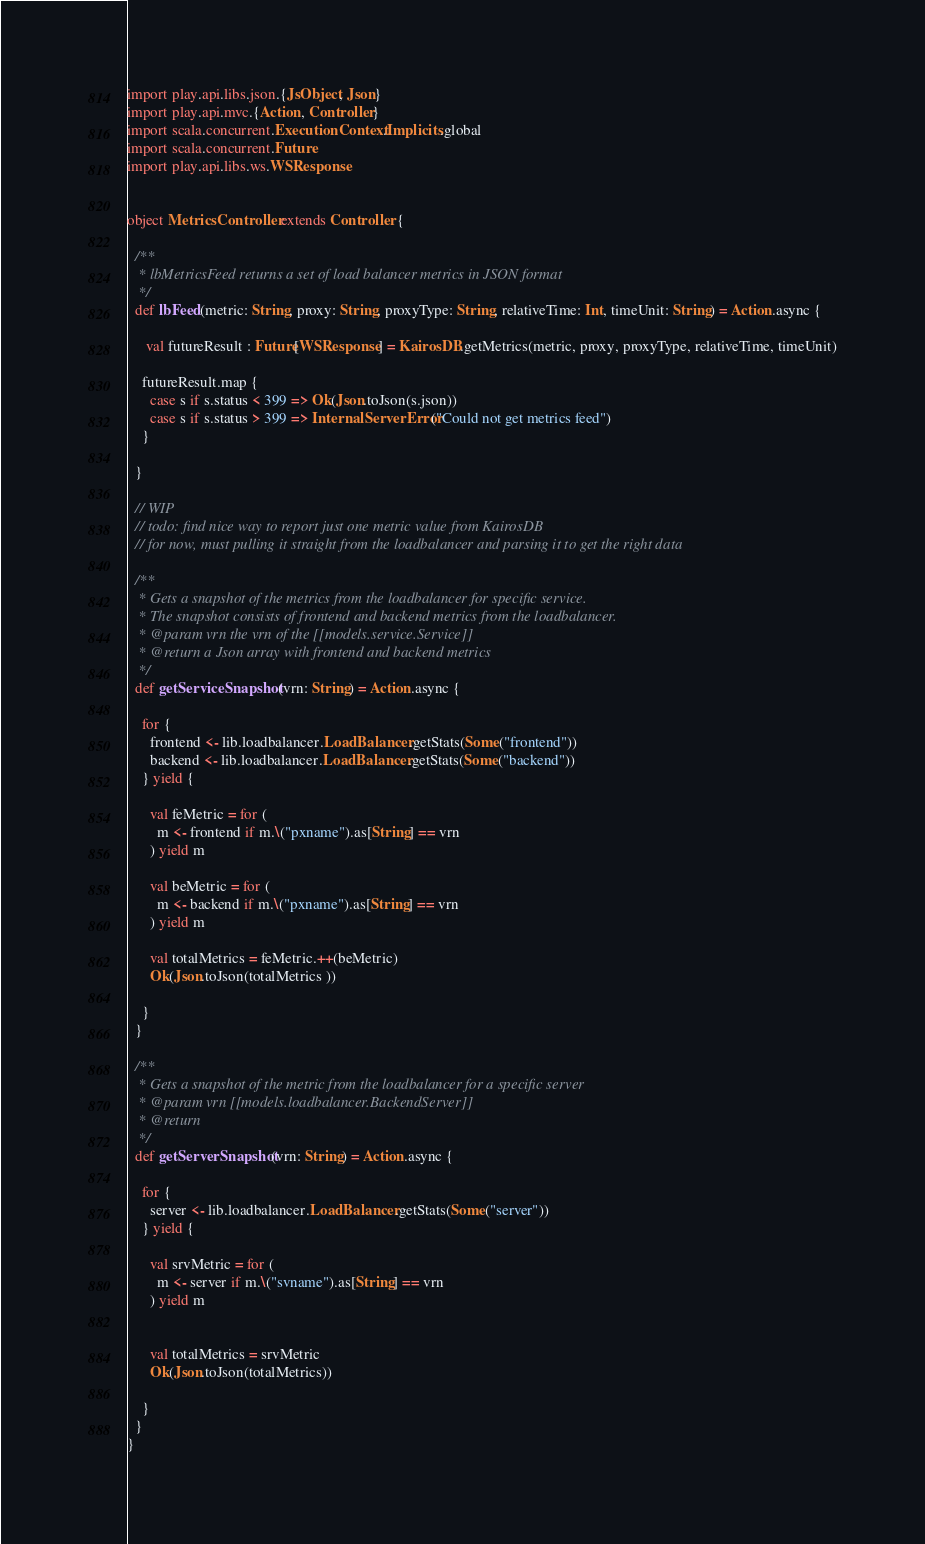Convert code to text. <code><loc_0><loc_0><loc_500><loc_500><_Scala_>import play.api.libs.json.{JsObject, Json}
import play.api.mvc.{Action, Controller}
import scala.concurrent.ExecutionContext.Implicits.global
import scala.concurrent.Future
import play.api.libs.ws.WSResponse


object MetricsController extends Controller {

  /**
   * lbMetricsFeed returns a set of load balancer metrics in JSON format
   */
  def lbFeed(metric: String, proxy: String, proxyType: String, relativeTime: Int, timeUnit: String) = Action.async {

     val futureResult : Future[WSResponse] = KairosDB.getMetrics(metric, proxy, proxyType, relativeTime, timeUnit)

    futureResult.map {
      case s if s.status < 399 => Ok(Json.toJson(s.json))
      case s if s.status > 399 => InternalServerError("Could not get metrics feed")
    }

  }

  // WIP
  // todo: find nice way to report just one metric value from KairosDB
  // for now, must pulling it straight from the loadbalancer and parsing it to get the right data

  /**
   * Gets a snapshot of the metrics from the loadbalancer for specific service.
   * The snapshot consists of frontend and backend metrics from the loadbalancer.
   * @param vrn the vrn of the [[models.service.Service]]
   * @return a Json array with frontend and backend metrics
   */
  def getServiceSnapshot(vrn: String) = Action.async {

    for {
      frontend <- lib.loadbalancer.LoadBalancer.getStats(Some("frontend"))
      backend <- lib.loadbalancer.LoadBalancer.getStats(Some("backend"))
    } yield {

      val feMetric = for (
        m <- frontend if m.\("pxname").as[String] == vrn
      ) yield m

      val beMetric = for (
        m <- backend if m.\("pxname").as[String] == vrn
      ) yield m

      val totalMetrics = feMetric.++(beMetric)
      Ok(Json.toJson(totalMetrics ))

    }
  }

  /**
   * Gets a snapshot of the metric from the loadbalancer for a specific server
   * @param vrn [[models.loadbalancer.BackendServer]]
   * @return
   */
  def getServerSnapshot(vrn: String) = Action.async {

    for {
      server <- lib.loadbalancer.LoadBalancer.getStats(Some("server"))
    } yield {

      val srvMetric = for (
        m <- server if m.\("svname").as[String] == vrn
      ) yield m


      val totalMetrics = srvMetric
      Ok(Json.toJson(totalMetrics))

    }
  }
}

</code> 